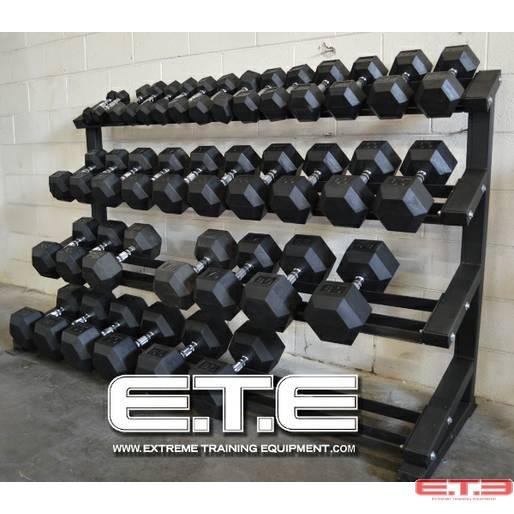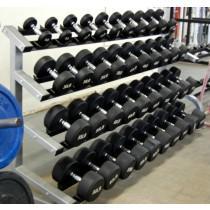The first image is the image on the left, the second image is the image on the right. Evaluate the accuracy of this statement regarding the images: "There is a human near dumbells in one of the images.". Is it true? Answer yes or no. No. 